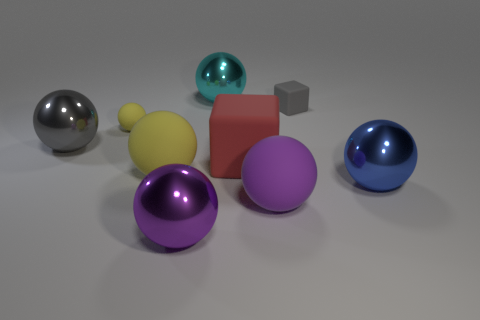How many other objects are there of the same shape as the purple metallic thing?
Ensure brevity in your answer.  6. What is the size of the yellow object that is in front of the tiny rubber sphere?
Your response must be concise. Large. What number of large blue things are left of the tiny matte thing that is on the right side of the purple rubber thing?
Your answer should be compact. 0. How many other things are there of the same size as the red matte cube?
Your response must be concise. 6. Do the small block and the big block have the same color?
Offer a very short reply. No. There is a matte thing in front of the blue object; is its shape the same as the blue shiny thing?
Your response must be concise. Yes. What number of spheres are in front of the gray matte object and behind the gray ball?
Provide a succinct answer. 1. What material is the gray ball?
Your answer should be very brief. Metal. Is there anything else that is the same color as the big block?
Give a very brief answer. No. Does the large gray object have the same material as the tiny ball?
Your answer should be very brief. No. 